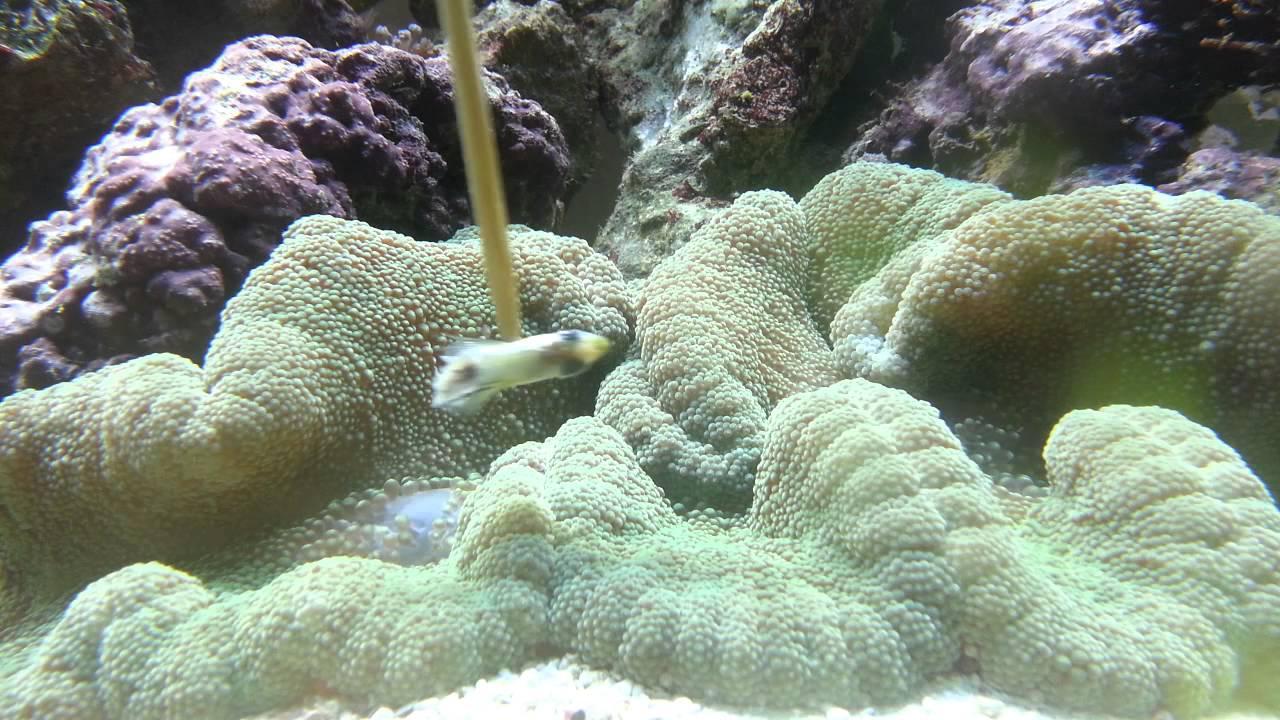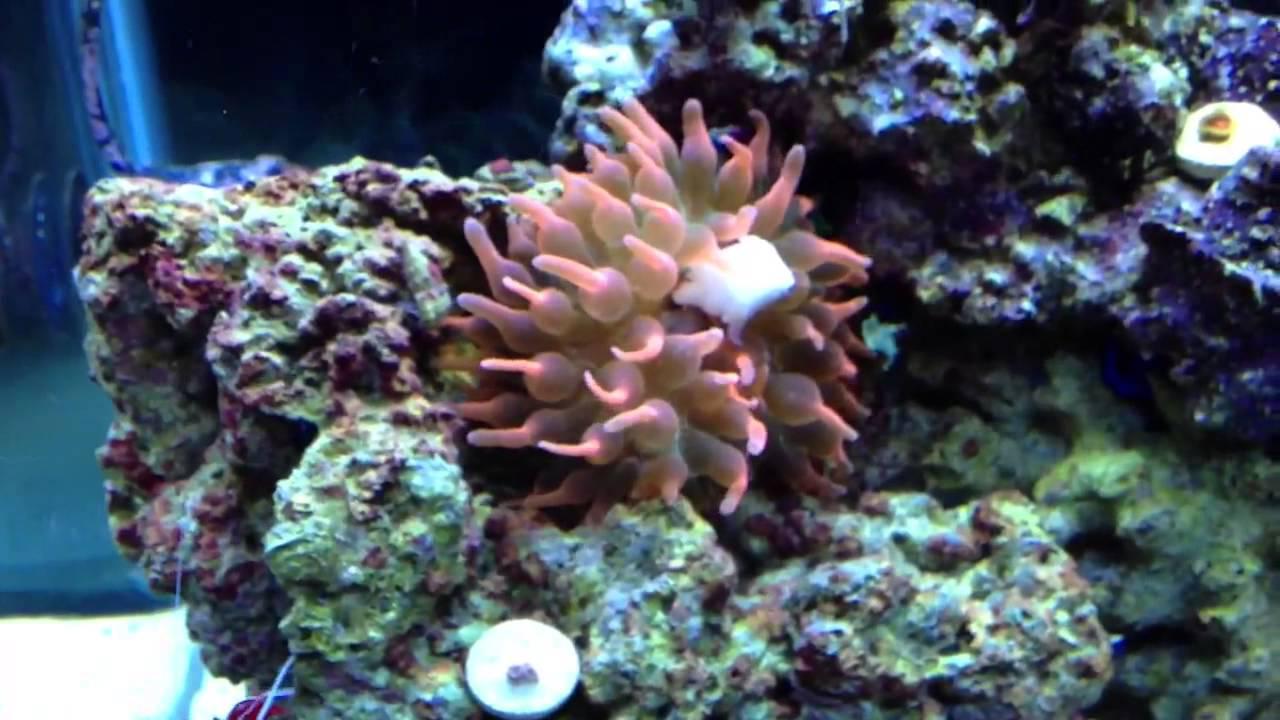The first image is the image on the left, the second image is the image on the right. For the images shown, is this caption "In at least one image there is at least one striped fish  swimming in corral." true? Answer yes or no. No. The first image is the image on the left, the second image is the image on the right. For the images shown, is this caption "At least one fish with bold stripes is positioned over the tendrils of an anemone in the left image." true? Answer yes or no. No. 